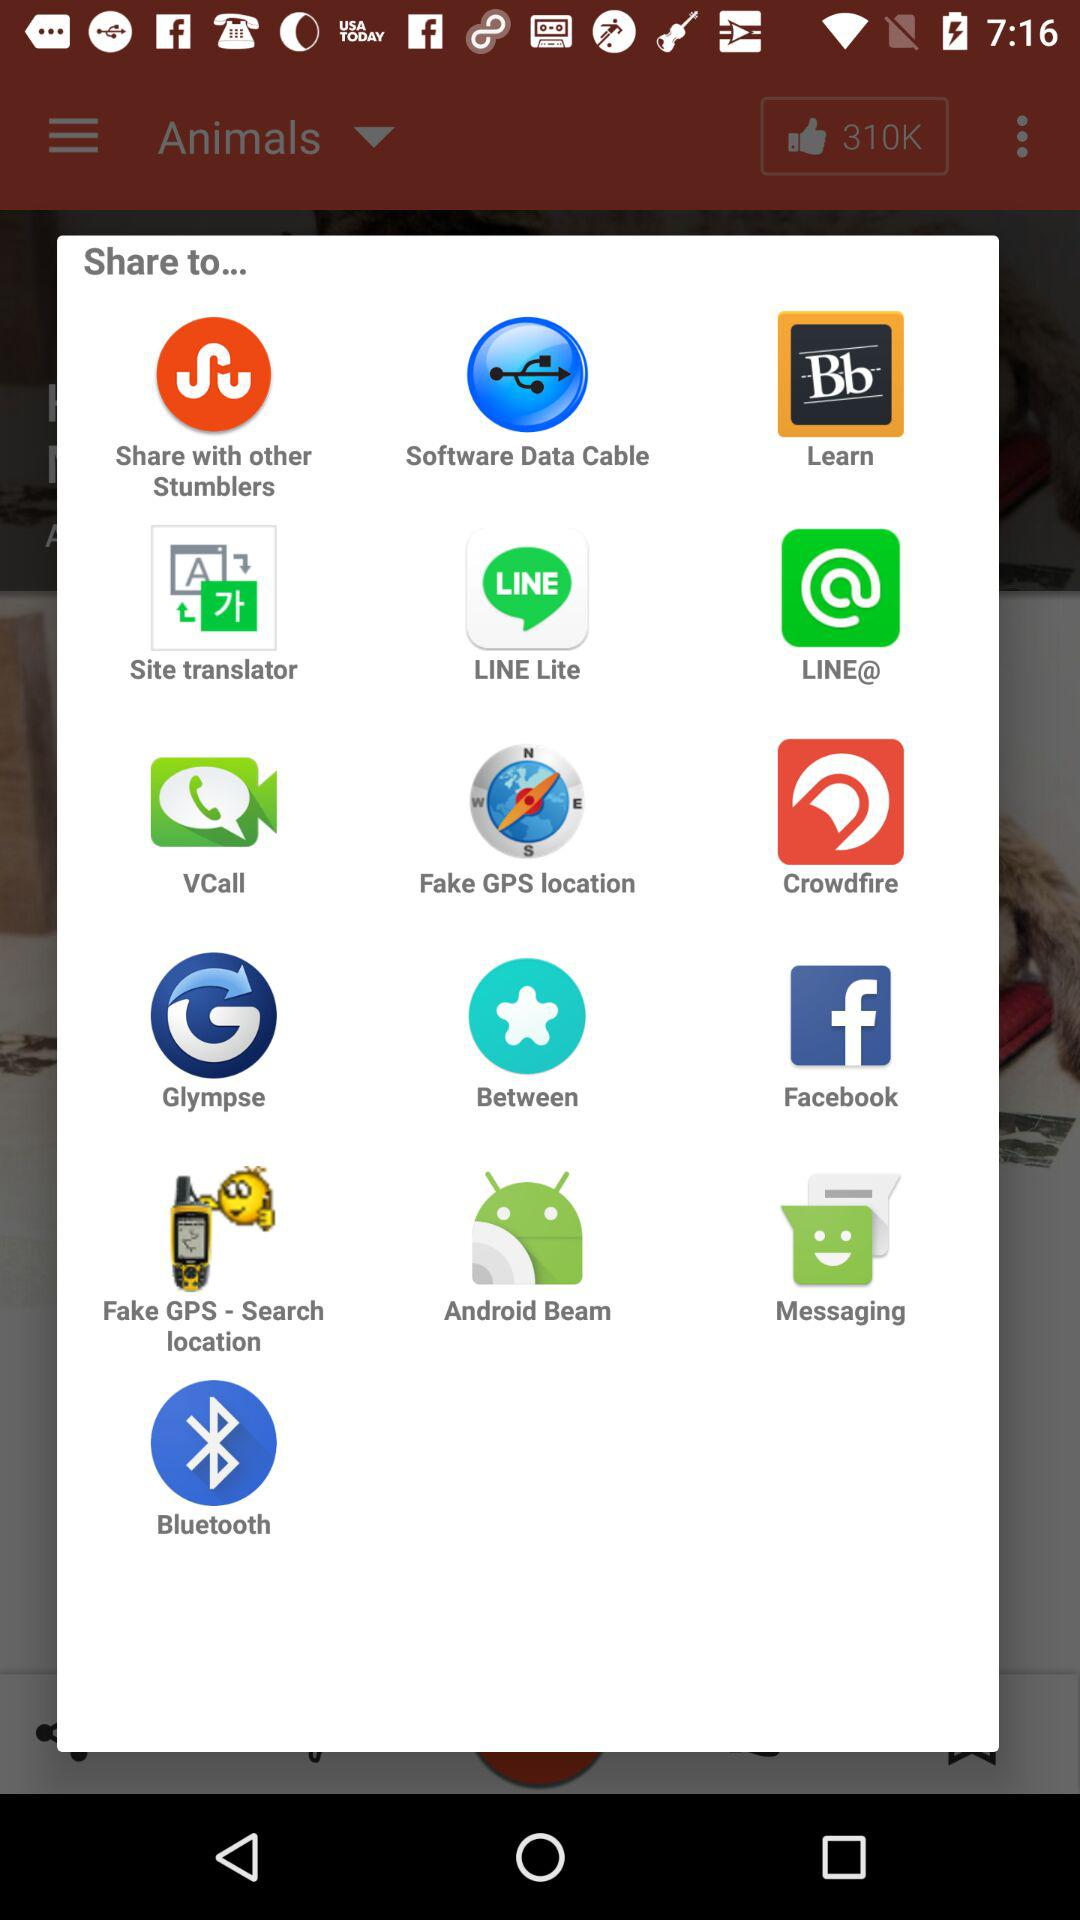Through which applications can we share? You can share through "Stumbler", "Software Data Cable", "Learn", "Site translator", "LINE Lite", "LINE@", "VCall", "Fake GPS location", "Crowdfire", "Glympse", "Between", "Facebook", "Fake GPS - Search location", "Android Beam", "Messaging" and "Bluetooth". 